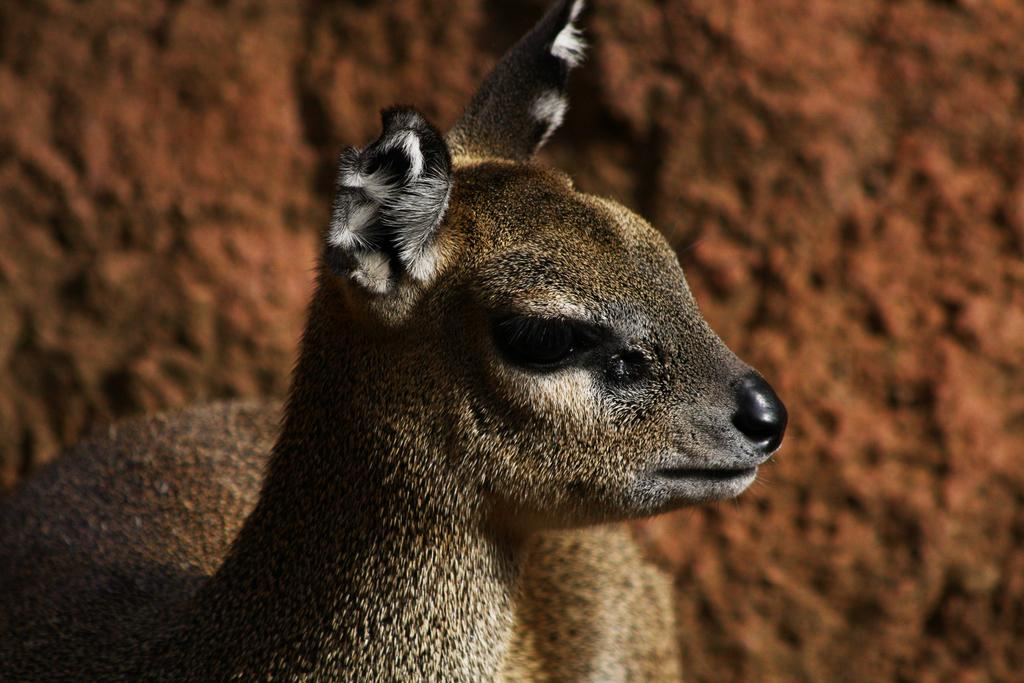What is the main subject in the center of the image? There is an animal in the center of the image. Can you describe the colors of the animal? The animal has black and brown colors. What can be seen in the background of the image? There is a wall in the background of the image. How many slices of pie does the girl have in the image? There is no girl or pie present in the image; it features an animal with black and brown colors and a wall in the background. 